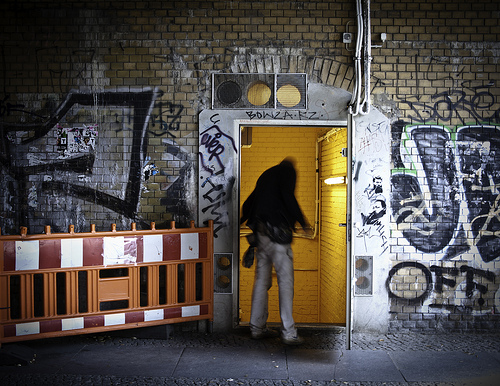What story might the graffiti beside the yellow door tell about this urban space? The graffiti depicts various expressive forms and tags that signify a rich, albeit rebellious, cultural interaction among the city's youth. It speaks to the vibrant life that flows through this often overlooked alley, illustrating themes of resistance and creativity. How does the color of the door contrast with the surrounding graffiti? The bright yellow door stands out strikingly against the dark tones of the surrounding graffiti-filled walls, acting as a beacon of order and an escape to mundane reality amidst the chaotic swirls of color. 